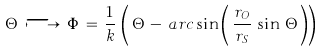Convert formula to latex. <formula><loc_0><loc_0><loc_500><loc_500>\Theta \, \longmapsto \, \Phi \, = \, \frac { 1 } { k } \, \left ( \, \Theta \, - \, a r c \sin \left ( \, \frac { r _ { O } } { r _ { S } } \, \sin \, \Theta \, \right ) \right )</formula> 